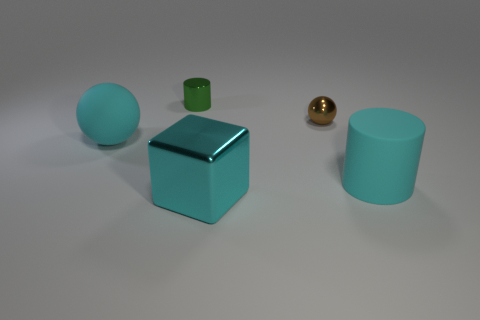Are there fewer cyan objects to the right of the brown metallic ball than cyan shiny blocks?
Offer a terse response. No. Does the big object that is to the left of the green cylinder have the same material as the brown object?
Your answer should be compact. No. There is a thing that is made of the same material as the big cyan ball; what color is it?
Offer a terse response. Cyan. Are there fewer big cyan blocks on the left side of the cyan metal object than things right of the green metallic object?
Make the answer very short. Yes. There is a big rubber thing on the right side of the metal cylinder; is it the same color as the metal thing in front of the cyan rubber sphere?
Your answer should be very brief. Yes. Is there another tiny green thing made of the same material as the green object?
Offer a terse response. No. How big is the shiny object in front of the big thing that is behind the cyan cylinder?
Offer a terse response. Large. Is the number of cyan spheres greater than the number of small gray metal balls?
Provide a succinct answer. Yes. There is a metallic object that is in front of the rubber cylinder; is its size the same as the metal cylinder?
Make the answer very short. No. What number of balls have the same color as the big metal block?
Your answer should be very brief. 1. 